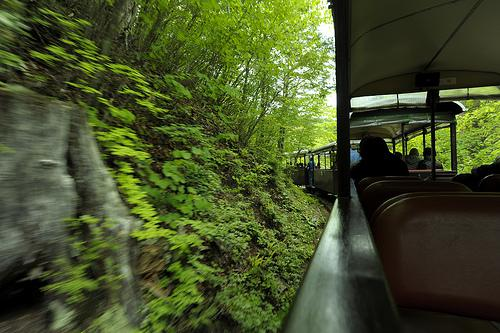Question: what is on the ground?
Choices:
A. Grass.
B. Plants.
C. Snow.
D. Ice.
Answer with the letter. Answer: B Question: who is the subject of the photo?
Choices:
A. Nature.
B. Animals.
C. People.
D. Buildings.
Answer with the letter. Answer: A Question: how is the picture being taken?
Choices:
A. From inside a car.
B. From a photographer on the beach.
C. From inside a building.
D. By the photographer on the train.
Answer with the letter. Answer: D Question: when was this photo taken?
Choices:
A. During the night.
B. At dusk.
C. During the day.
D. At dawn.
Answer with the letter. Answer: C Question: why is the photo blurry?
Choices:
A. Because the photgrapher moved.
B. Because the subject of the photo is moving.
C. Because the train is moving.
D. Because the camera is broken.
Answer with the letter. Answer: C 